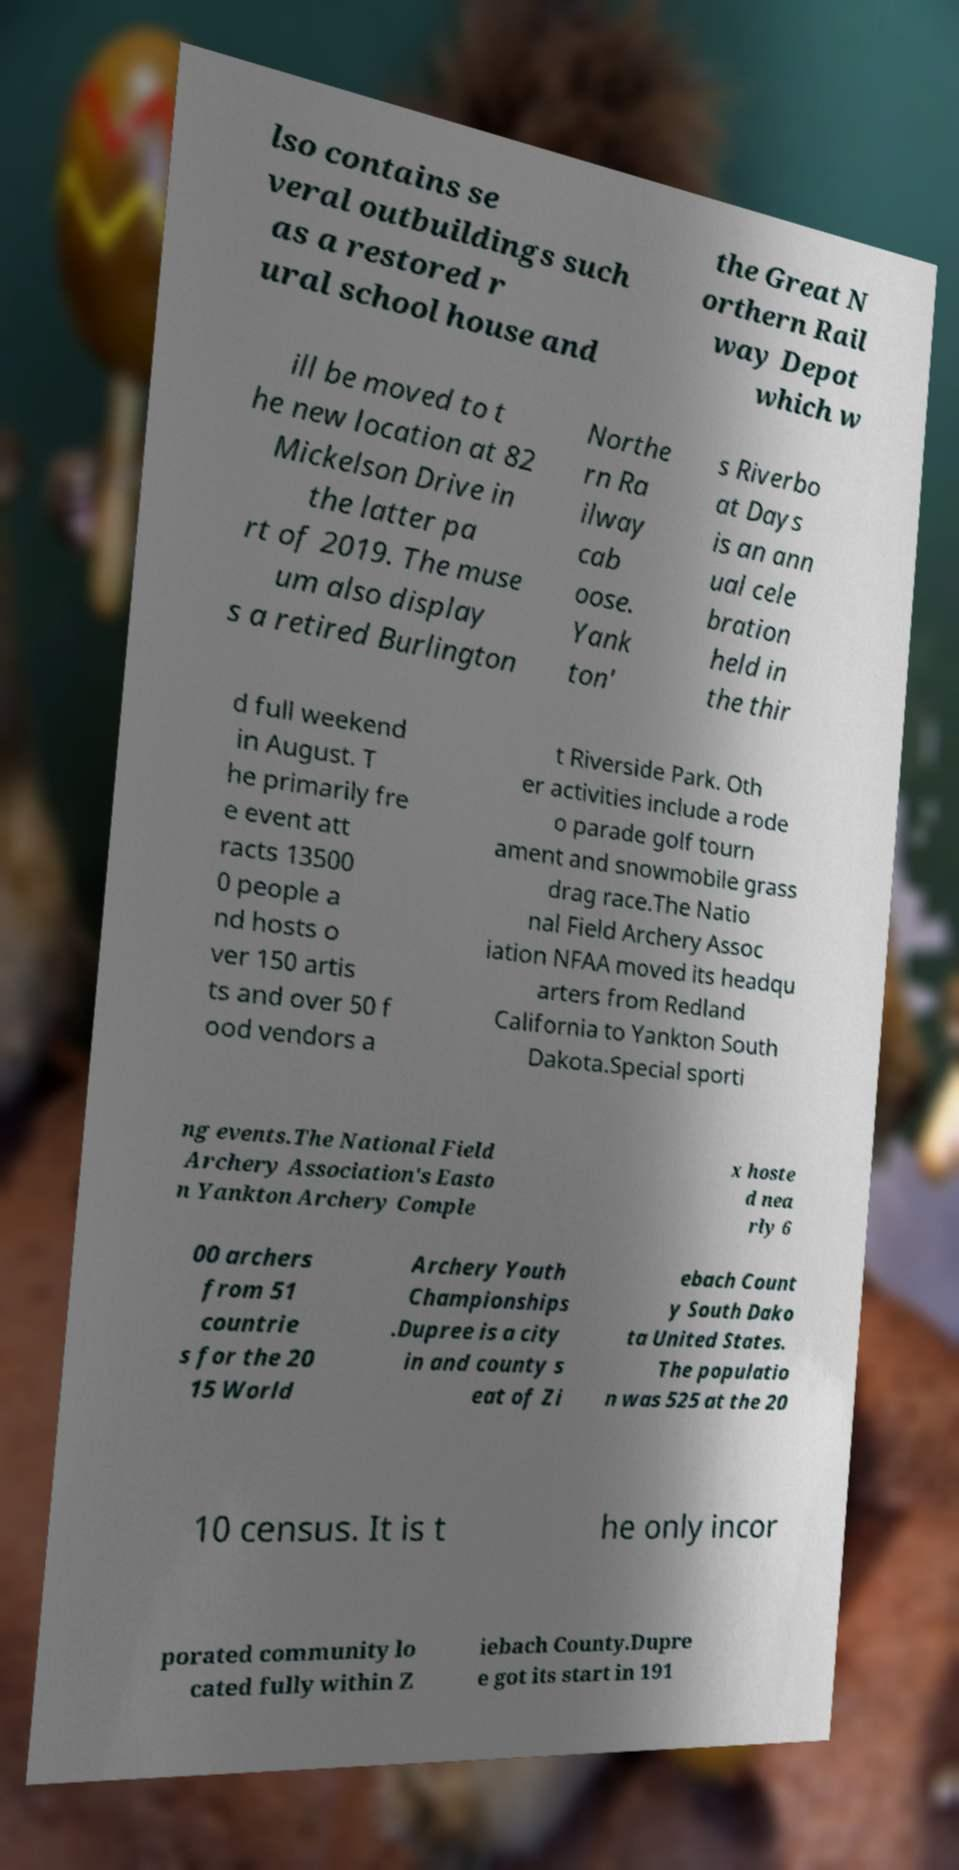What messages or text are displayed in this image? I need them in a readable, typed format. lso contains se veral outbuildings such as a restored r ural school house and the Great N orthern Rail way Depot which w ill be moved to t he new location at 82 Mickelson Drive in the latter pa rt of 2019. The muse um also display s a retired Burlington Northe rn Ra ilway cab oose. Yank ton' s Riverbo at Days is an ann ual cele bration held in the thir d full weekend in August. T he primarily fre e event att racts 13500 0 people a nd hosts o ver 150 artis ts and over 50 f ood vendors a t Riverside Park. Oth er activities include a rode o parade golf tourn ament and snowmobile grass drag race.The Natio nal Field Archery Assoc iation NFAA moved its headqu arters from Redland California to Yankton South Dakota.Special sporti ng events.The National Field Archery Association's Easto n Yankton Archery Comple x hoste d nea rly 6 00 archers from 51 countrie s for the 20 15 World Archery Youth Championships .Dupree is a city in and county s eat of Zi ebach Count y South Dako ta United States. The populatio n was 525 at the 20 10 census. It is t he only incor porated community lo cated fully within Z iebach County.Dupre e got its start in 191 